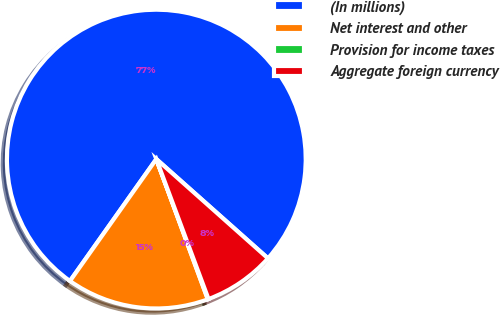Convert chart. <chart><loc_0><loc_0><loc_500><loc_500><pie_chart><fcel>(In millions)<fcel>Net interest and other<fcel>Provision for income taxes<fcel>Aggregate foreign currency<nl><fcel>76.76%<fcel>15.41%<fcel>0.08%<fcel>7.75%<nl></chart> 